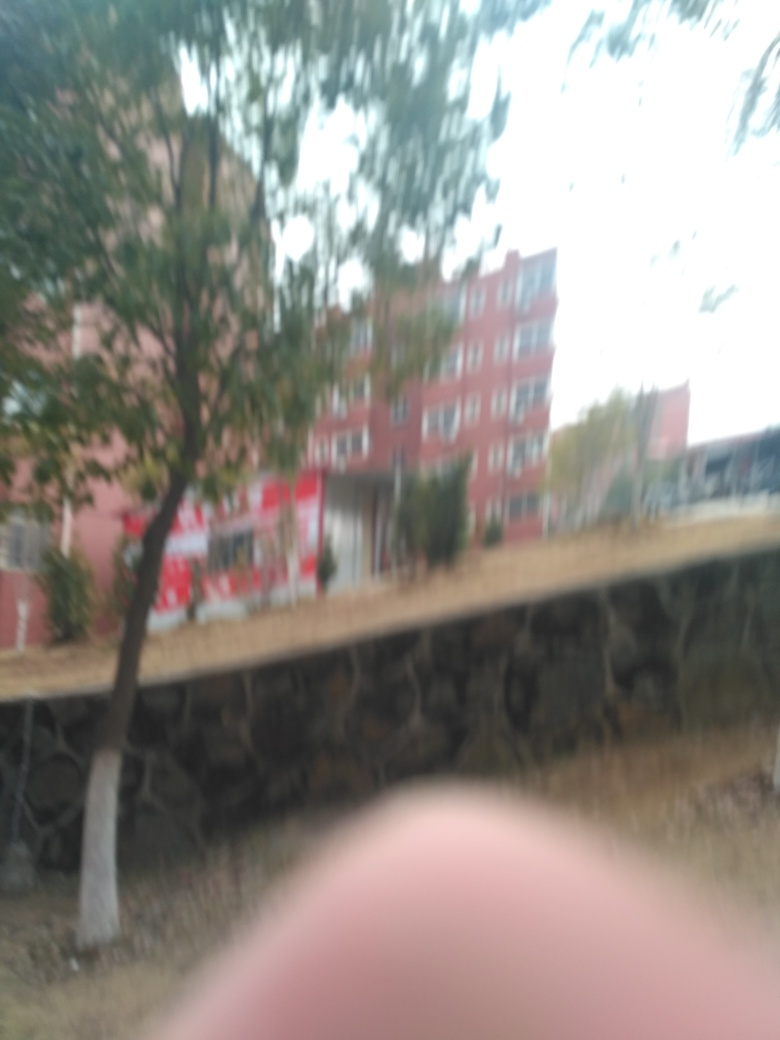How is the overall sharpness of this image?
A. Exceptional
B. Very low
C. High
D. Excellent
Answer with the option's letter from the given choices directly.
 B. 